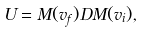Convert formula to latex. <formula><loc_0><loc_0><loc_500><loc_500>U = M ( v _ { f } ) D M ( v _ { i } ) ,</formula> 